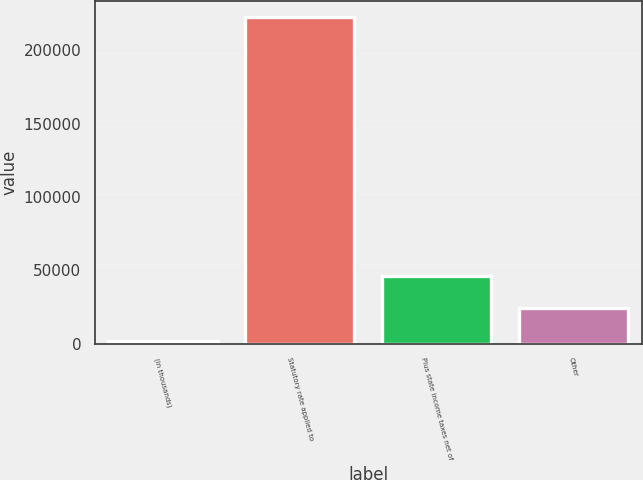<chart> <loc_0><loc_0><loc_500><loc_500><bar_chart><fcel>(in thousands)<fcel>Statutory rate applied to<fcel>Plus state income taxes net of<fcel>Other<nl><fcel>2004<fcel>222572<fcel>46117.6<fcel>24060.8<nl></chart> 